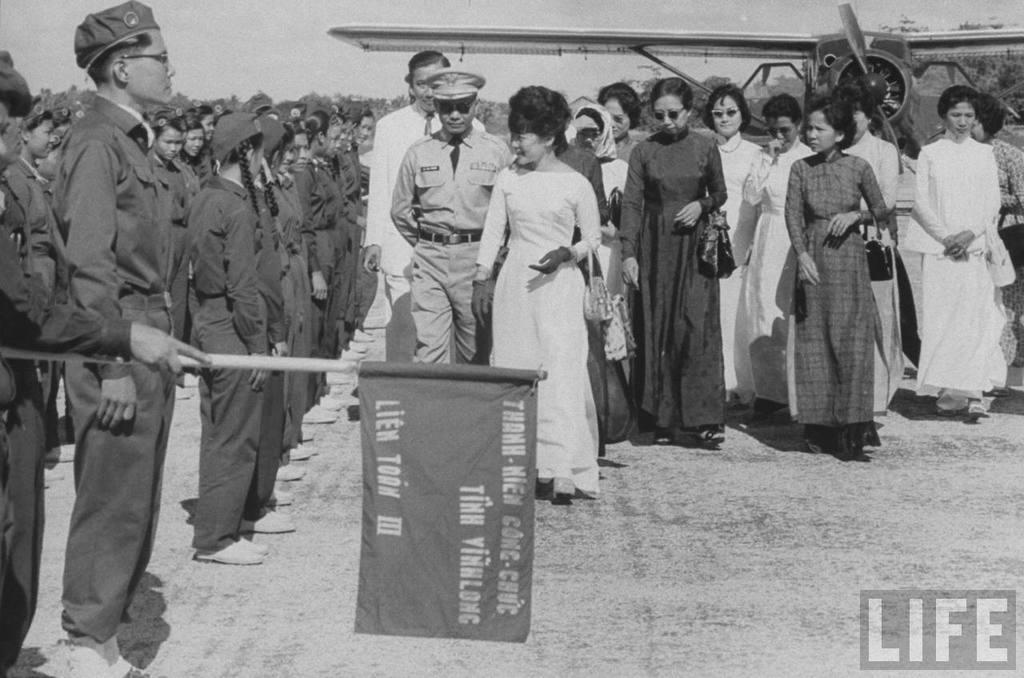<image>
Write a terse but informative summary of the picture. An old photo taken by Life magazine shows a man holding a flag that reads Lien Toon III 